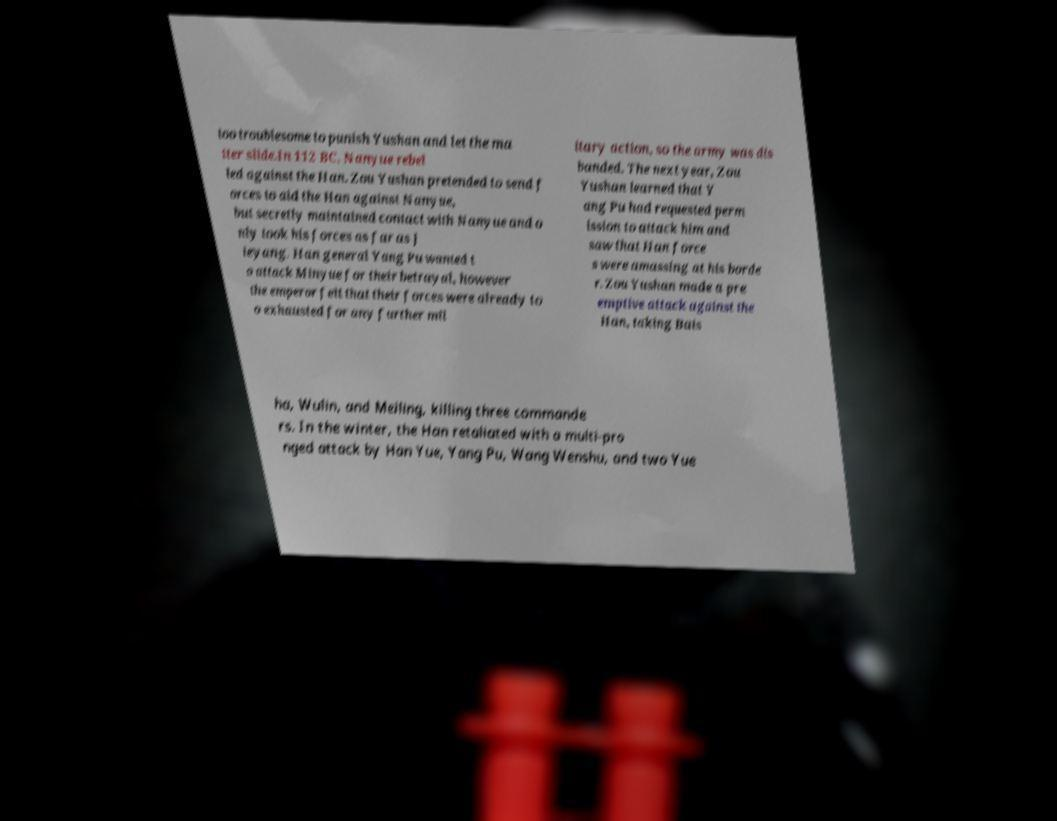Could you assist in decoding the text presented in this image and type it out clearly? too troublesome to punish Yushan and let the ma tter slide.In 112 BC, Nanyue rebel led against the Han. Zou Yushan pretended to send f orces to aid the Han against Nanyue, but secretly maintained contact with Nanyue and o nly took his forces as far as J ieyang. Han general Yang Pu wanted t o attack Minyue for their betrayal, however the emperor felt that their forces were already to o exhausted for any further mil itary action, so the army was dis banded. The next year, Zou Yushan learned that Y ang Pu had requested perm ission to attack him and saw that Han force s were amassing at his borde r. Zou Yushan made a pre emptive attack against the Han, taking Bais ha, Wulin, and Meiling, killing three commande rs. In the winter, the Han retaliated with a multi-pro nged attack by Han Yue, Yang Pu, Wang Wenshu, and two Yue 